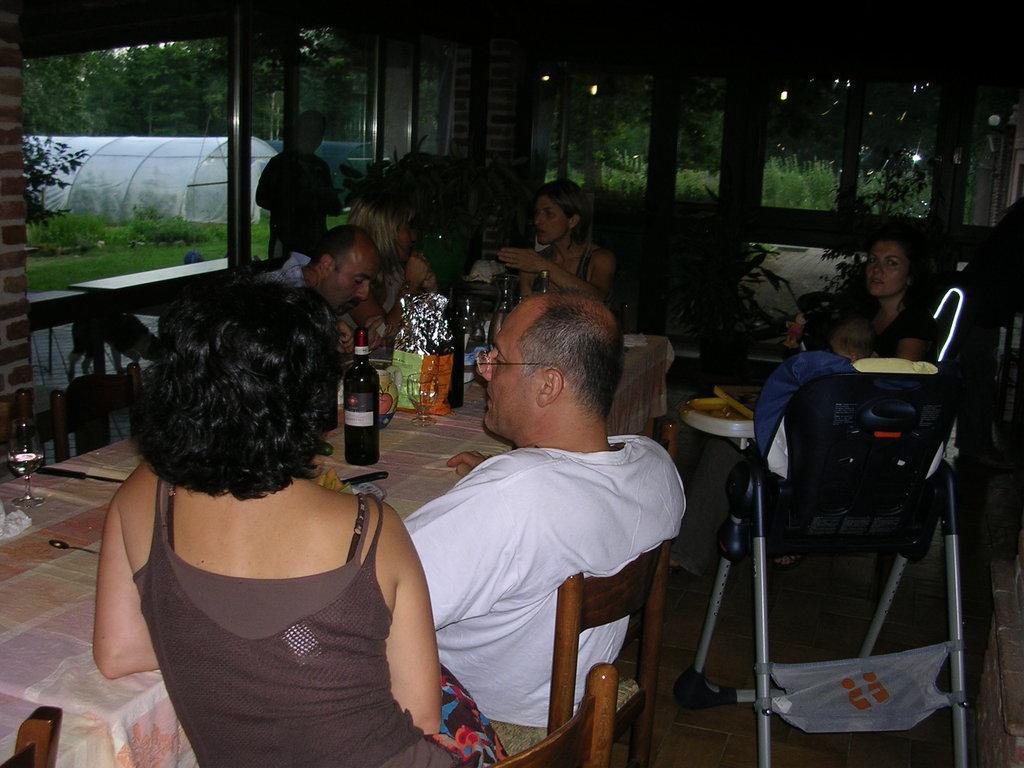Could you give a brief overview of what you see in this image? In this picture we can see some persons are sitting on the chairs. This is the table, and there is a cloth on the table. Here we can see some bottles, glasses on the table. And this is the baby stroller. On the background we can see some trees. And this is the grass. 